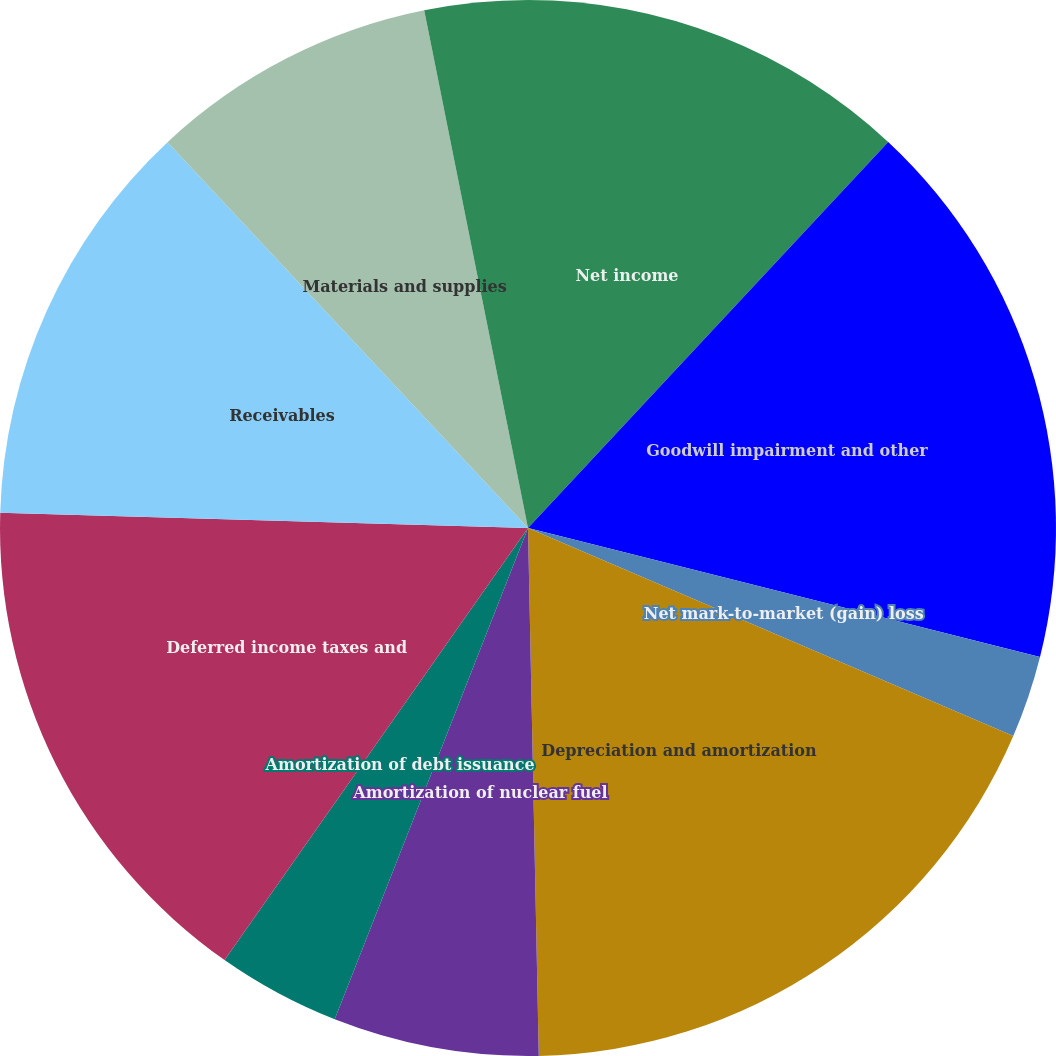Convert chart. <chart><loc_0><loc_0><loc_500><loc_500><pie_chart><fcel>Net income<fcel>Goodwill impairment and other<fcel>Net mark-to-market (gain) loss<fcel>Depreciation and amortization<fcel>Amortization of nuclear fuel<fcel>Amortization of debt issuance<fcel>Deferred income taxes and<fcel>Receivables<fcel>Materials and supplies<fcel>Accounts and wages payable<nl><fcel>11.95%<fcel>16.98%<fcel>2.52%<fcel>18.23%<fcel>6.29%<fcel>3.78%<fcel>15.72%<fcel>12.58%<fcel>8.81%<fcel>3.15%<nl></chart> 